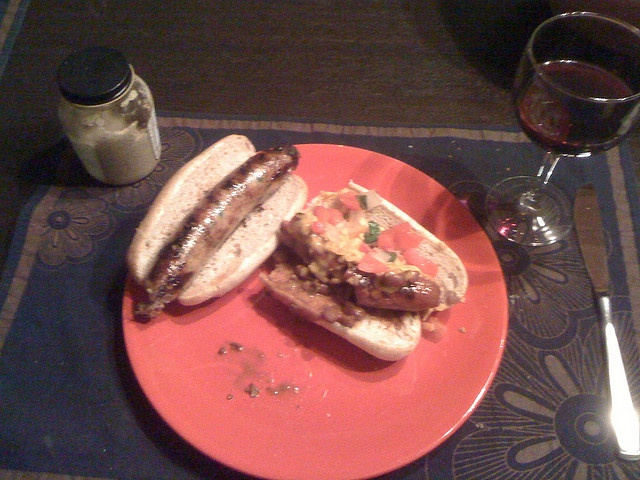Describe the objects in this image and their specific colors. I can see dining table in black, salmon, maroon, gray, and purple tones, wine glass in black, maroon, and gray tones, hot dog in black, brown, maroon, and salmon tones, and knife in black, white, brown, and maroon tones in this image. 